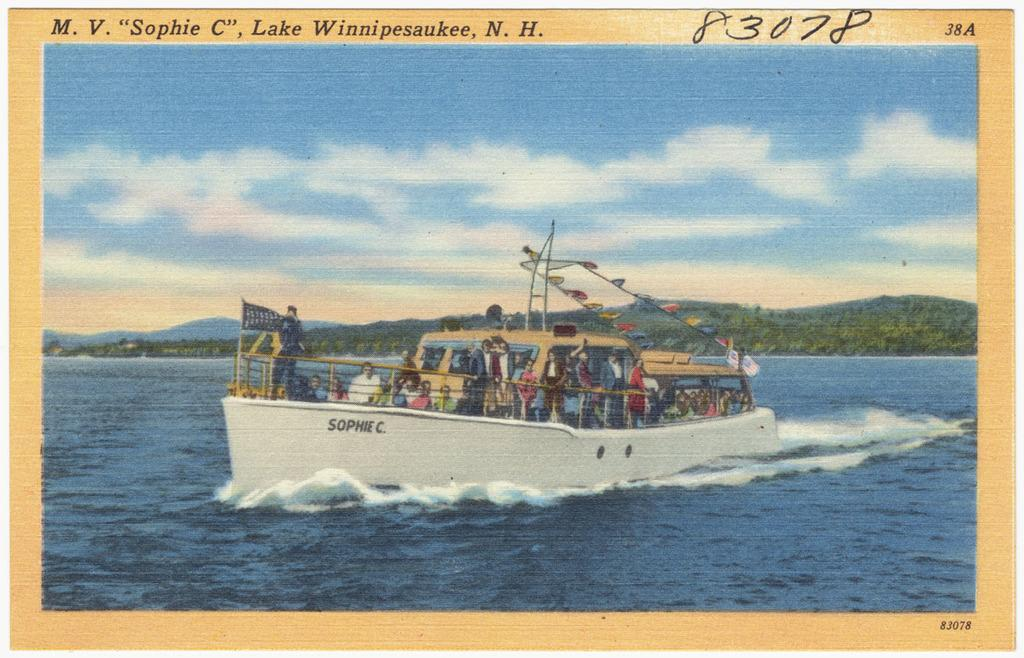Provide a one-sentence caption for the provided image. A colorful postcard that is captioned M.V Sophie C, Lake Winnipesaukee, N.H. 